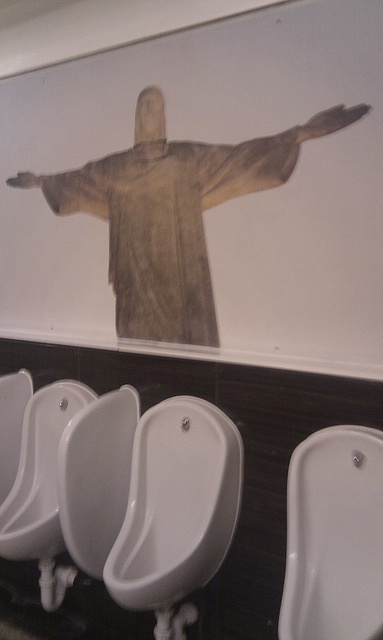Describe the objects in this image and their specific colors. I can see toilet in gray, darkgray, and black tones and toilet in gray tones in this image. 